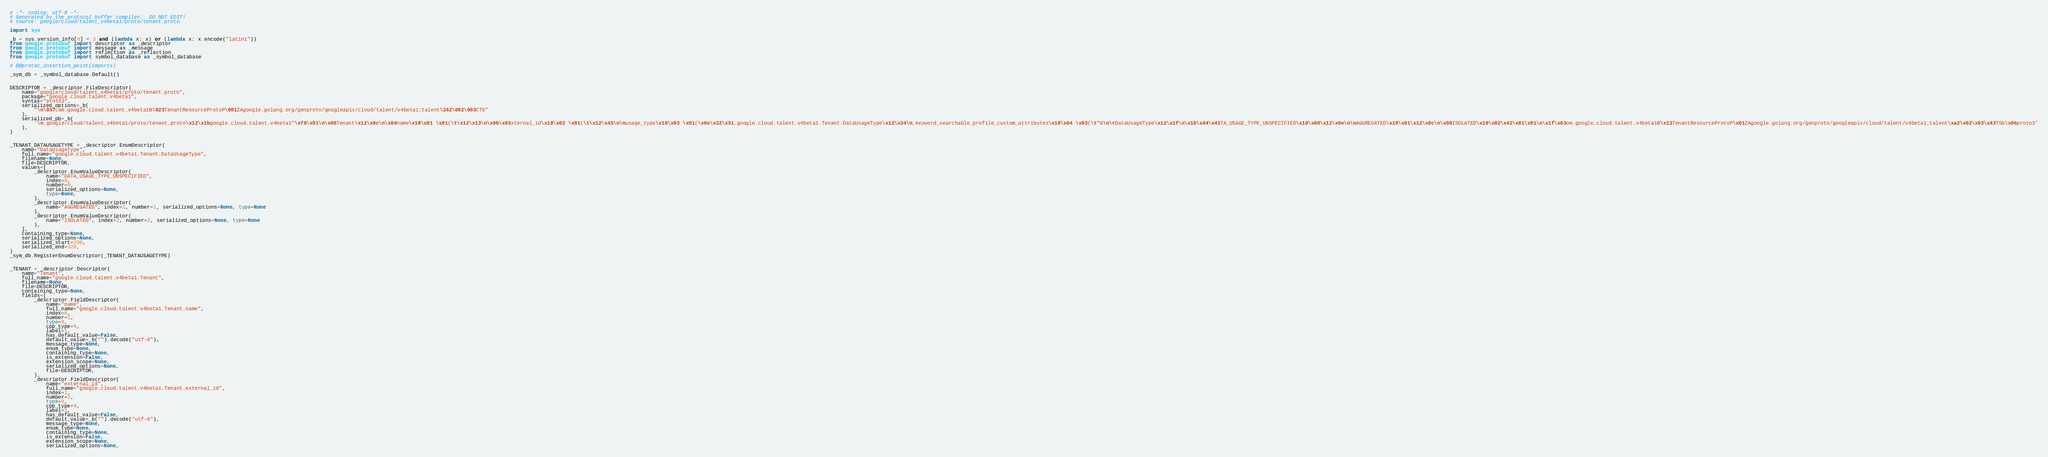Convert code to text. <code><loc_0><loc_0><loc_500><loc_500><_Python_># -*- coding: utf-8 -*-
# Generated by the protocol buffer compiler.  DO NOT EDIT!
# source: google/cloud/talent_v4beta1/proto/tenant.proto

import sys

_b = sys.version_info[0] < 3 and (lambda x: x) or (lambda x: x.encode("latin1"))
from google.protobuf import descriptor as _descriptor
from google.protobuf import message as _message
from google.protobuf import reflection as _reflection
from google.protobuf import symbol_database as _symbol_database

# @@protoc_insertion_point(imports)

_sym_db = _symbol_database.Default()


DESCRIPTOR = _descriptor.FileDescriptor(
    name="google/cloud/talent_v4beta1/proto/tenant.proto",
    package="google.cloud.talent.v4beta1",
    syntax="proto3",
    serialized_options=_b(
        "\n\037com.google.cloud.talent.v4beta1B\023TenantResourceProtoP\001ZAgoogle.golang.org/genproto/googleapis/cloud/talent/v4beta1;talent\242\002\003CTS"
    ),
    serialized_pb=_b(
        '\n.google/cloud/talent_v4beta1/proto/tenant.proto\x12\x1bgoogle.cloud.talent.v4beta1"\xf8\x01\n\x06Tenant\x12\x0c\n\x04name\x18\x01 \x01(\t\x12\x13\n\x0b\x65xternal_id\x18\x02 \x01(\t\x12\x45\n\nusage_type\x18\x03 \x01(\x0e\x32\x31.google.cloud.talent.v4beta1.Tenant.DataUsageType\x12\x34\n,keyword_searchable_profile_custom_attributes\x18\x04 \x03(\t"N\n\rDataUsageType\x12\x1f\n\x1b\x44\x41TA_USAGE_TYPE_UNSPECIFIED\x10\x00\x12\x0e\n\nAGGREGATED\x10\x01\x12\x0c\n\x08ISOLATED\x10\x02\x42\x81\x01\n\x1f\x63om.google.cloud.talent.v4beta1B\x13TenantResourceProtoP\x01ZAgoogle.golang.org/genproto/googleapis/cloud/talent/v4beta1;talent\xa2\x02\x03\x43TSb\x06proto3'
    ),
)


_TENANT_DATAUSAGETYPE = _descriptor.EnumDescriptor(
    name="DataUsageType",
    full_name="google.cloud.talent.v4beta1.Tenant.DataUsageType",
    filename=None,
    file=DESCRIPTOR,
    values=[
        _descriptor.EnumValueDescriptor(
            name="DATA_USAGE_TYPE_UNSPECIFIED",
            index=0,
            number=0,
            serialized_options=None,
            type=None,
        ),
        _descriptor.EnumValueDescriptor(
            name="AGGREGATED", index=1, number=1, serialized_options=None, type=None
        ),
        _descriptor.EnumValueDescriptor(
            name="ISOLATED", index=2, number=2, serialized_options=None, type=None
        ),
    ],
    containing_type=None,
    serialized_options=None,
    serialized_start=250,
    serialized_end=328,
)
_sym_db.RegisterEnumDescriptor(_TENANT_DATAUSAGETYPE)


_TENANT = _descriptor.Descriptor(
    name="Tenant",
    full_name="google.cloud.talent.v4beta1.Tenant",
    filename=None,
    file=DESCRIPTOR,
    containing_type=None,
    fields=[
        _descriptor.FieldDescriptor(
            name="name",
            full_name="google.cloud.talent.v4beta1.Tenant.name",
            index=0,
            number=1,
            type=9,
            cpp_type=9,
            label=1,
            has_default_value=False,
            default_value=_b("").decode("utf-8"),
            message_type=None,
            enum_type=None,
            containing_type=None,
            is_extension=False,
            extension_scope=None,
            serialized_options=None,
            file=DESCRIPTOR,
        ),
        _descriptor.FieldDescriptor(
            name="external_id",
            full_name="google.cloud.talent.v4beta1.Tenant.external_id",
            index=1,
            number=2,
            type=9,
            cpp_type=9,
            label=1,
            has_default_value=False,
            default_value=_b("").decode("utf-8"),
            message_type=None,
            enum_type=None,
            containing_type=None,
            is_extension=False,
            extension_scope=None,
            serialized_options=None,</code> 